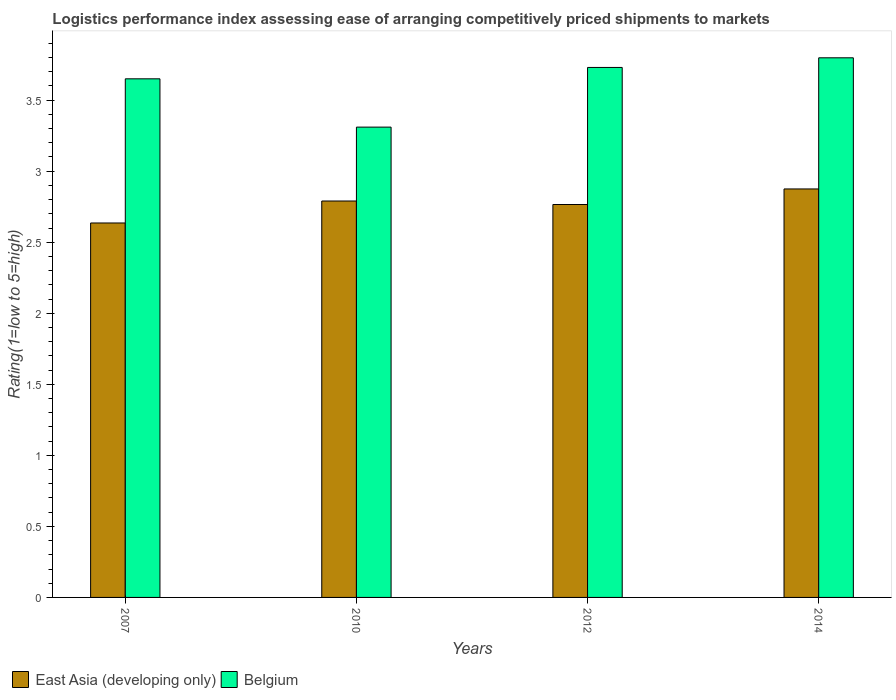How many different coloured bars are there?
Provide a short and direct response. 2. How many groups of bars are there?
Make the answer very short. 4. Are the number of bars per tick equal to the number of legend labels?
Provide a succinct answer. Yes. How many bars are there on the 2nd tick from the left?
Your answer should be very brief. 2. What is the Logistic performance index in East Asia (developing only) in 2007?
Provide a short and direct response. 2.64. Across all years, what is the maximum Logistic performance index in East Asia (developing only)?
Make the answer very short. 2.87. Across all years, what is the minimum Logistic performance index in Belgium?
Give a very brief answer. 3.31. In which year was the Logistic performance index in East Asia (developing only) maximum?
Keep it short and to the point. 2014. In which year was the Logistic performance index in Belgium minimum?
Your response must be concise. 2010. What is the total Logistic performance index in Belgium in the graph?
Your answer should be very brief. 14.49. What is the difference between the Logistic performance index in East Asia (developing only) in 2010 and that in 2014?
Your answer should be compact. -0.08. What is the difference between the Logistic performance index in East Asia (developing only) in 2007 and the Logistic performance index in Belgium in 2010?
Your answer should be compact. -0.67. What is the average Logistic performance index in East Asia (developing only) per year?
Offer a very short reply. 2.77. In the year 2012, what is the difference between the Logistic performance index in Belgium and Logistic performance index in East Asia (developing only)?
Provide a succinct answer. 0.96. In how many years, is the Logistic performance index in Belgium greater than 2?
Your answer should be compact. 4. What is the ratio of the Logistic performance index in East Asia (developing only) in 2010 to that in 2012?
Your response must be concise. 1.01. Is the Logistic performance index in Belgium in 2010 less than that in 2014?
Ensure brevity in your answer.  Yes. What is the difference between the highest and the second highest Logistic performance index in East Asia (developing only)?
Give a very brief answer. 0.08. What is the difference between the highest and the lowest Logistic performance index in Belgium?
Offer a very short reply. 0.49. In how many years, is the Logistic performance index in East Asia (developing only) greater than the average Logistic performance index in East Asia (developing only) taken over all years?
Provide a short and direct response. 2. Is the sum of the Logistic performance index in Belgium in 2010 and 2012 greater than the maximum Logistic performance index in East Asia (developing only) across all years?
Make the answer very short. Yes. What does the 2nd bar from the left in 2012 represents?
Offer a terse response. Belgium. What does the 1st bar from the right in 2014 represents?
Make the answer very short. Belgium. Are all the bars in the graph horizontal?
Your answer should be very brief. No. How many years are there in the graph?
Offer a terse response. 4. Are the values on the major ticks of Y-axis written in scientific E-notation?
Keep it short and to the point. No. Does the graph contain any zero values?
Your answer should be compact. No. How many legend labels are there?
Your answer should be compact. 2. How are the legend labels stacked?
Your answer should be compact. Horizontal. What is the title of the graph?
Ensure brevity in your answer.  Logistics performance index assessing ease of arranging competitively priced shipments to markets. Does "Switzerland" appear as one of the legend labels in the graph?
Ensure brevity in your answer.  No. What is the label or title of the X-axis?
Make the answer very short. Years. What is the label or title of the Y-axis?
Keep it short and to the point. Rating(1=low to 5=high). What is the Rating(1=low to 5=high) of East Asia (developing only) in 2007?
Offer a terse response. 2.64. What is the Rating(1=low to 5=high) of Belgium in 2007?
Keep it short and to the point. 3.65. What is the Rating(1=low to 5=high) in East Asia (developing only) in 2010?
Your response must be concise. 2.79. What is the Rating(1=low to 5=high) of Belgium in 2010?
Keep it short and to the point. 3.31. What is the Rating(1=low to 5=high) of East Asia (developing only) in 2012?
Keep it short and to the point. 2.77. What is the Rating(1=low to 5=high) in Belgium in 2012?
Your response must be concise. 3.73. What is the Rating(1=low to 5=high) in East Asia (developing only) in 2014?
Offer a terse response. 2.87. What is the Rating(1=low to 5=high) in Belgium in 2014?
Provide a short and direct response. 3.8. Across all years, what is the maximum Rating(1=low to 5=high) of East Asia (developing only)?
Your answer should be very brief. 2.87. Across all years, what is the maximum Rating(1=low to 5=high) of Belgium?
Your answer should be very brief. 3.8. Across all years, what is the minimum Rating(1=low to 5=high) in East Asia (developing only)?
Make the answer very short. 2.64. Across all years, what is the minimum Rating(1=low to 5=high) in Belgium?
Make the answer very short. 3.31. What is the total Rating(1=low to 5=high) in East Asia (developing only) in the graph?
Your answer should be very brief. 11.07. What is the total Rating(1=low to 5=high) in Belgium in the graph?
Offer a terse response. 14.49. What is the difference between the Rating(1=low to 5=high) in East Asia (developing only) in 2007 and that in 2010?
Provide a short and direct response. -0.15. What is the difference between the Rating(1=low to 5=high) in Belgium in 2007 and that in 2010?
Provide a succinct answer. 0.34. What is the difference between the Rating(1=low to 5=high) in East Asia (developing only) in 2007 and that in 2012?
Provide a succinct answer. -0.13. What is the difference between the Rating(1=low to 5=high) of Belgium in 2007 and that in 2012?
Your answer should be very brief. -0.08. What is the difference between the Rating(1=low to 5=high) of East Asia (developing only) in 2007 and that in 2014?
Your response must be concise. -0.24. What is the difference between the Rating(1=low to 5=high) of Belgium in 2007 and that in 2014?
Ensure brevity in your answer.  -0.15. What is the difference between the Rating(1=low to 5=high) in East Asia (developing only) in 2010 and that in 2012?
Keep it short and to the point. 0.02. What is the difference between the Rating(1=low to 5=high) in Belgium in 2010 and that in 2012?
Your answer should be very brief. -0.42. What is the difference between the Rating(1=low to 5=high) of East Asia (developing only) in 2010 and that in 2014?
Your response must be concise. -0.08. What is the difference between the Rating(1=low to 5=high) of Belgium in 2010 and that in 2014?
Keep it short and to the point. -0.49. What is the difference between the Rating(1=low to 5=high) in East Asia (developing only) in 2012 and that in 2014?
Offer a terse response. -0.11. What is the difference between the Rating(1=low to 5=high) of Belgium in 2012 and that in 2014?
Ensure brevity in your answer.  -0.07. What is the difference between the Rating(1=low to 5=high) in East Asia (developing only) in 2007 and the Rating(1=low to 5=high) in Belgium in 2010?
Make the answer very short. -0.67. What is the difference between the Rating(1=low to 5=high) in East Asia (developing only) in 2007 and the Rating(1=low to 5=high) in Belgium in 2012?
Provide a short and direct response. -1.09. What is the difference between the Rating(1=low to 5=high) in East Asia (developing only) in 2007 and the Rating(1=low to 5=high) in Belgium in 2014?
Your answer should be very brief. -1.16. What is the difference between the Rating(1=low to 5=high) of East Asia (developing only) in 2010 and the Rating(1=low to 5=high) of Belgium in 2012?
Provide a short and direct response. -0.94. What is the difference between the Rating(1=low to 5=high) of East Asia (developing only) in 2010 and the Rating(1=low to 5=high) of Belgium in 2014?
Keep it short and to the point. -1.01. What is the difference between the Rating(1=low to 5=high) in East Asia (developing only) in 2012 and the Rating(1=low to 5=high) in Belgium in 2014?
Your answer should be compact. -1.03. What is the average Rating(1=low to 5=high) in East Asia (developing only) per year?
Offer a terse response. 2.77. What is the average Rating(1=low to 5=high) in Belgium per year?
Ensure brevity in your answer.  3.62. In the year 2007, what is the difference between the Rating(1=low to 5=high) of East Asia (developing only) and Rating(1=low to 5=high) of Belgium?
Make the answer very short. -1.01. In the year 2010, what is the difference between the Rating(1=low to 5=high) in East Asia (developing only) and Rating(1=low to 5=high) in Belgium?
Keep it short and to the point. -0.52. In the year 2012, what is the difference between the Rating(1=low to 5=high) in East Asia (developing only) and Rating(1=low to 5=high) in Belgium?
Give a very brief answer. -0.96. In the year 2014, what is the difference between the Rating(1=low to 5=high) of East Asia (developing only) and Rating(1=low to 5=high) of Belgium?
Provide a short and direct response. -0.92. What is the ratio of the Rating(1=low to 5=high) in East Asia (developing only) in 2007 to that in 2010?
Provide a succinct answer. 0.94. What is the ratio of the Rating(1=low to 5=high) of Belgium in 2007 to that in 2010?
Ensure brevity in your answer.  1.1. What is the ratio of the Rating(1=low to 5=high) of East Asia (developing only) in 2007 to that in 2012?
Keep it short and to the point. 0.95. What is the ratio of the Rating(1=low to 5=high) in Belgium in 2007 to that in 2012?
Offer a terse response. 0.98. What is the ratio of the Rating(1=low to 5=high) of Belgium in 2007 to that in 2014?
Give a very brief answer. 0.96. What is the ratio of the Rating(1=low to 5=high) in East Asia (developing only) in 2010 to that in 2012?
Your response must be concise. 1.01. What is the ratio of the Rating(1=low to 5=high) in Belgium in 2010 to that in 2012?
Provide a succinct answer. 0.89. What is the ratio of the Rating(1=low to 5=high) of East Asia (developing only) in 2010 to that in 2014?
Your response must be concise. 0.97. What is the ratio of the Rating(1=low to 5=high) in Belgium in 2010 to that in 2014?
Offer a terse response. 0.87. What is the ratio of the Rating(1=low to 5=high) in East Asia (developing only) in 2012 to that in 2014?
Your answer should be very brief. 0.96. What is the ratio of the Rating(1=low to 5=high) in Belgium in 2012 to that in 2014?
Make the answer very short. 0.98. What is the difference between the highest and the second highest Rating(1=low to 5=high) in East Asia (developing only)?
Your answer should be compact. 0.08. What is the difference between the highest and the second highest Rating(1=low to 5=high) in Belgium?
Provide a succinct answer. 0.07. What is the difference between the highest and the lowest Rating(1=low to 5=high) of East Asia (developing only)?
Make the answer very short. 0.24. What is the difference between the highest and the lowest Rating(1=low to 5=high) of Belgium?
Offer a terse response. 0.49. 